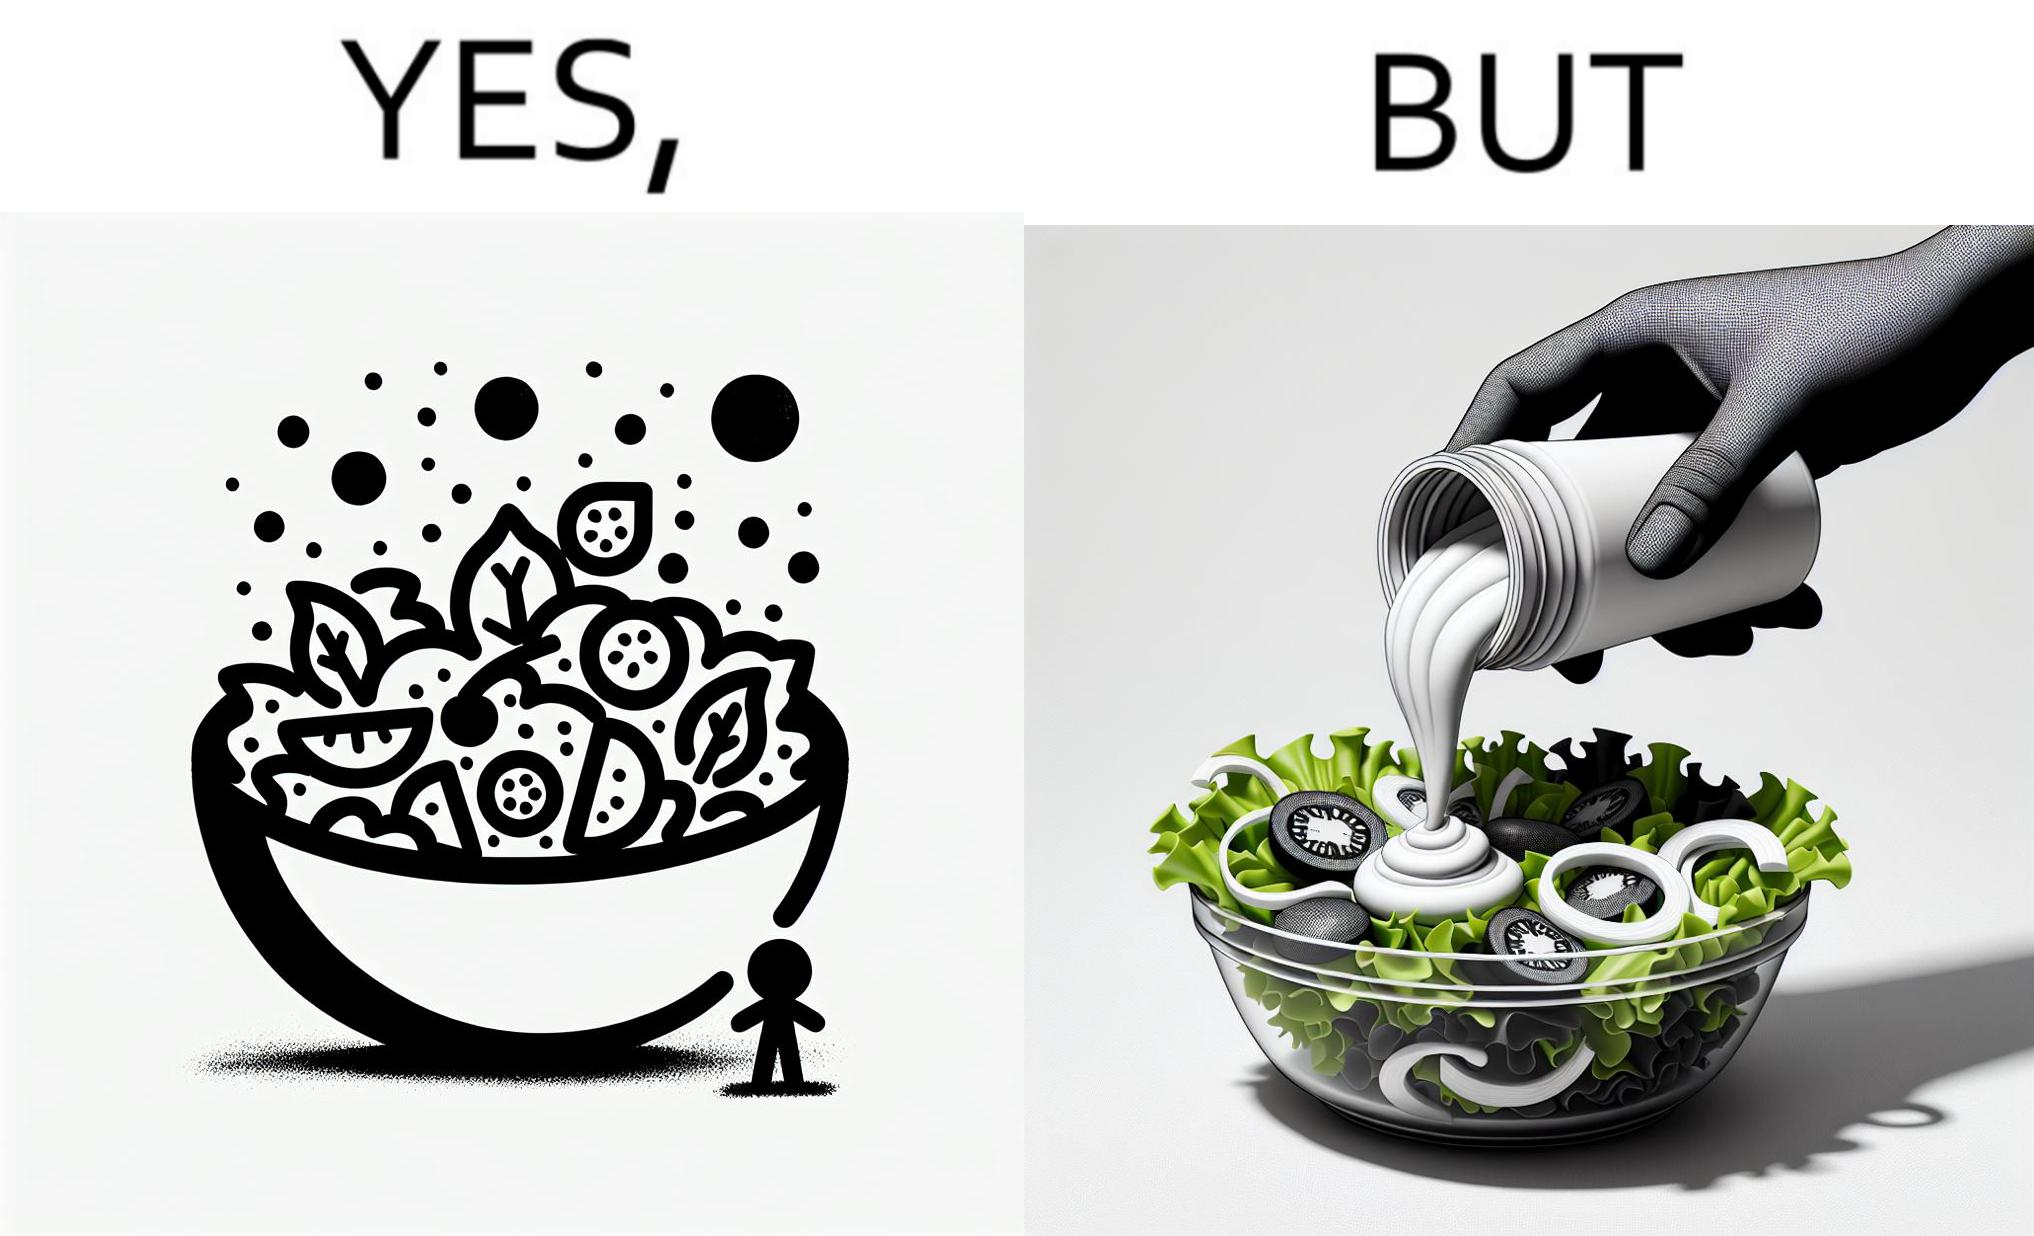What makes this image funny or satirical? The image is ironical, as salad in a bowl by itself is very healthy. However, when people have it with Mayonnaise sauce to improve the taste, it is not healthy anymore, and defeats the point of having nutrient-rich salad altogether. 